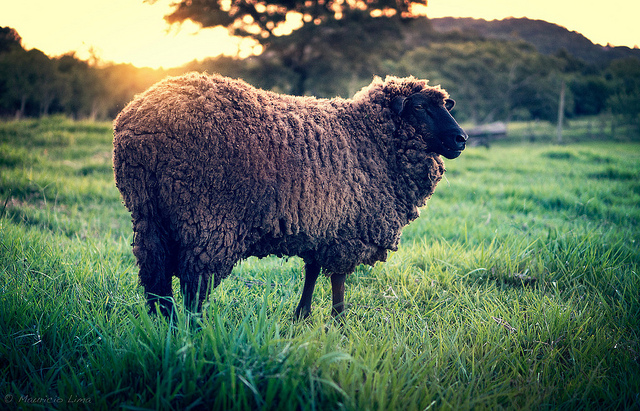How many sheep can you see in the photo? I can see only one sheep in the photo. It is prominently featured in the foreground, standing amidst tall grass and basking in the golden light of the sun. 